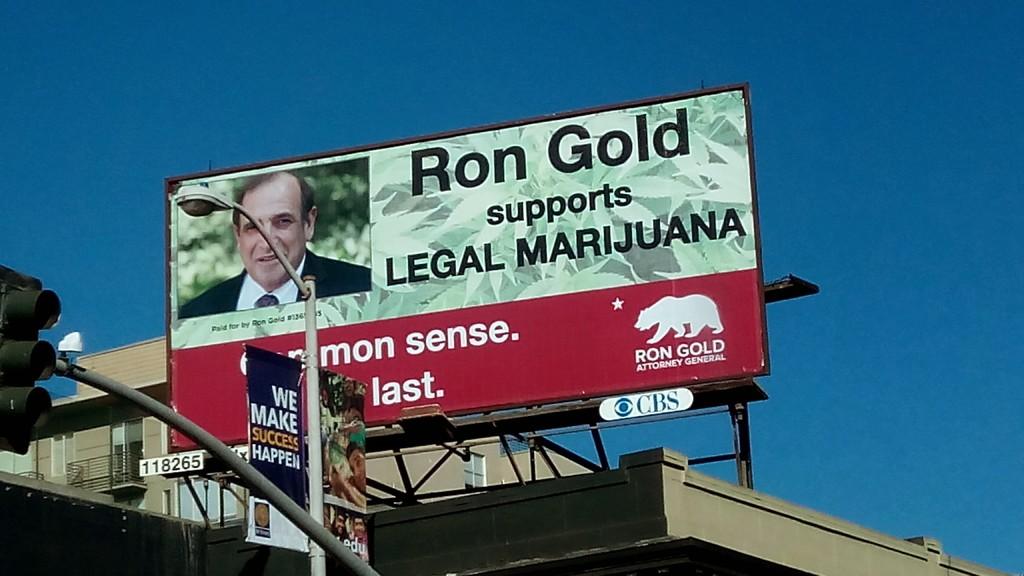What does ron gold support?
Your answer should be compact. Legal marijuana. Who is on the board?
Offer a terse response. Ron gold. 